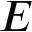<formula> <loc_0><loc_0><loc_500><loc_500>E</formula> 